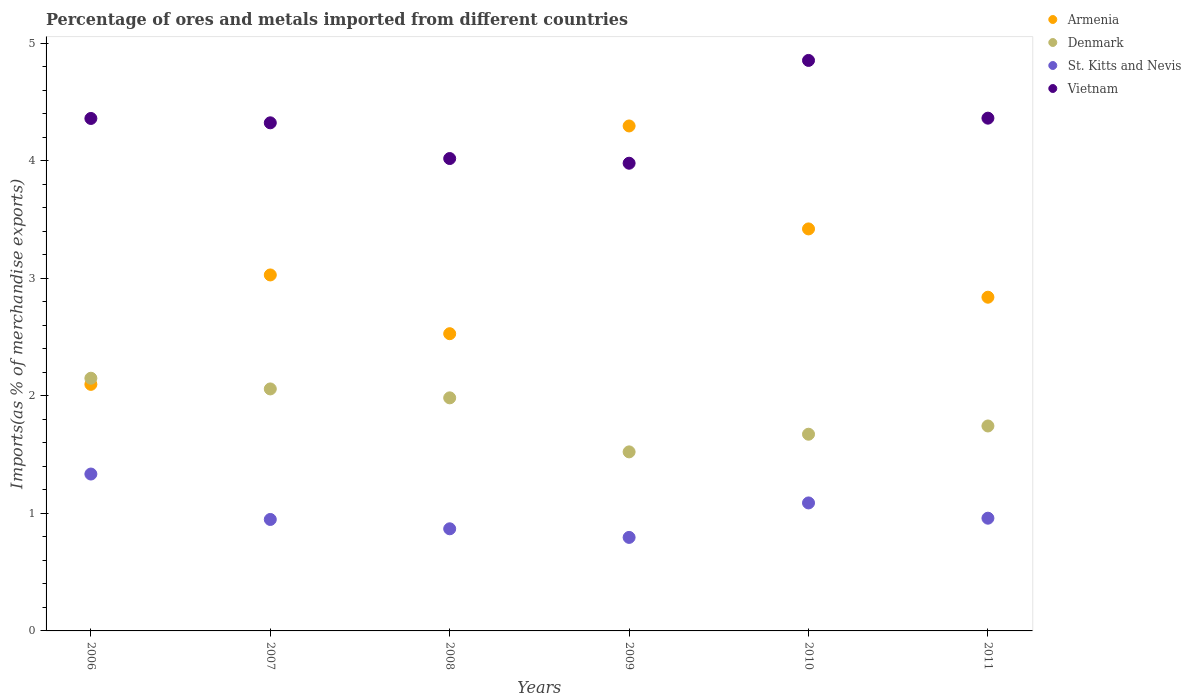How many different coloured dotlines are there?
Ensure brevity in your answer.  4. What is the percentage of imports to different countries in Vietnam in 2009?
Your answer should be compact. 3.98. Across all years, what is the maximum percentage of imports to different countries in Denmark?
Give a very brief answer. 2.15. Across all years, what is the minimum percentage of imports to different countries in Denmark?
Give a very brief answer. 1.52. In which year was the percentage of imports to different countries in Vietnam maximum?
Make the answer very short. 2010. What is the total percentage of imports to different countries in Denmark in the graph?
Provide a succinct answer. 11.13. What is the difference between the percentage of imports to different countries in St. Kitts and Nevis in 2006 and that in 2011?
Provide a short and direct response. 0.38. What is the difference between the percentage of imports to different countries in Denmark in 2011 and the percentage of imports to different countries in Armenia in 2009?
Your response must be concise. -2.55. What is the average percentage of imports to different countries in Armenia per year?
Give a very brief answer. 3.04. In the year 2010, what is the difference between the percentage of imports to different countries in Denmark and percentage of imports to different countries in St. Kitts and Nevis?
Give a very brief answer. 0.58. What is the ratio of the percentage of imports to different countries in Denmark in 2008 to that in 2009?
Offer a terse response. 1.3. Is the difference between the percentage of imports to different countries in Denmark in 2008 and 2009 greater than the difference between the percentage of imports to different countries in St. Kitts and Nevis in 2008 and 2009?
Make the answer very short. Yes. What is the difference between the highest and the second highest percentage of imports to different countries in St. Kitts and Nevis?
Offer a very short reply. 0.25. What is the difference between the highest and the lowest percentage of imports to different countries in Denmark?
Keep it short and to the point. 0.63. In how many years, is the percentage of imports to different countries in Armenia greater than the average percentage of imports to different countries in Armenia taken over all years?
Keep it short and to the point. 2. Is it the case that in every year, the sum of the percentage of imports to different countries in Denmark and percentage of imports to different countries in St. Kitts and Nevis  is greater than the sum of percentage of imports to different countries in Vietnam and percentage of imports to different countries in Armenia?
Keep it short and to the point. Yes. Is it the case that in every year, the sum of the percentage of imports to different countries in Denmark and percentage of imports to different countries in Vietnam  is greater than the percentage of imports to different countries in Armenia?
Offer a terse response. Yes. How many dotlines are there?
Offer a terse response. 4. Does the graph contain any zero values?
Give a very brief answer. No. Does the graph contain grids?
Offer a very short reply. No. How many legend labels are there?
Give a very brief answer. 4. How are the legend labels stacked?
Your answer should be very brief. Vertical. What is the title of the graph?
Offer a terse response. Percentage of ores and metals imported from different countries. What is the label or title of the Y-axis?
Give a very brief answer. Imports(as % of merchandise exports). What is the Imports(as % of merchandise exports) of Armenia in 2006?
Your answer should be very brief. 2.1. What is the Imports(as % of merchandise exports) in Denmark in 2006?
Provide a short and direct response. 2.15. What is the Imports(as % of merchandise exports) in St. Kitts and Nevis in 2006?
Provide a short and direct response. 1.33. What is the Imports(as % of merchandise exports) of Vietnam in 2006?
Ensure brevity in your answer.  4.36. What is the Imports(as % of merchandise exports) in Armenia in 2007?
Offer a very short reply. 3.03. What is the Imports(as % of merchandise exports) in Denmark in 2007?
Offer a very short reply. 2.06. What is the Imports(as % of merchandise exports) in St. Kitts and Nevis in 2007?
Your answer should be compact. 0.95. What is the Imports(as % of merchandise exports) of Vietnam in 2007?
Provide a succinct answer. 4.32. What is the Imports(as % of merchandise exports) of Armenia in 2008?
Give a very brief answer. 2.53. What is the Imports(as % of merchandise exports) in Denmark in 2008?
Provide a succinct answer. 1.98. What is the Imports(as % of merchandise exports) in St. Kitts and Nevis in 2008?
Your answer should be compact. 0.87. What is the Imports(as % of merchandise exports) of Vietnam in 2008?
Your answer should be compact. 4.02. What is the Imports(as % of merchandise exports) of Armenia in 2009?
Give a very brief answer. 4.3. What is the Imports(as % of merchandise exports) of Denmark in 2009?
Your answer should be very brief. 1.52. What is the Imports(as % of merchandise exports) in St. Kitts and Nevis in 2009?
Give a very brief answer. 0.8. What is the Imports(as % of merchandise exports) of Vietnam in 2009?
Provide a short and direct response. 3.98. What is the Imports(as % of merchandise exports) in Armenia in 2010?
Your response must be concise. 3.42. What is the Imports(as % of merchandise exports) of Denmark in 2010?
Your answer should be very brief. 1.67. What is the Imports(as % of merchandise exports) in St. Kitts and Nevis in 2010?
Provide a short and direct response. 1.09. What is the Imports(as % of merchandise exports) in Vietnam in 2010?
Keep it short and to the point. 4.85. What is the Imports(as % of merchandise exports) of Armenia in 2011?
Ensure brevity in your answer.  2.84. What is the Imports(as % of merchandise exports) of Denmark in 2011?
Make the answer very short. 1.74. What is the Imports(as % of merchandise exports) in St. Kitts and Nevis in 2011?
Provide a succinct answer. 0.96. What is the Imports(as % of merchandise exports) in Vietnam in 2011?
Provide a succinct answer. 4.36. Across all years, what is the maximum Imports(as % of merchandise exports) of Armenia?
Give a very brief answer. 4.3. Across all years, what is the maximum Imports(as % of merchandise exports) of Denmark?
Offer a very short reply. 2.15. Across all years, what is the maximum Imports(as % of merchandise exports) of St. Kitts and Nevis?
Offer a very short reply. 1.33. Across all years, what is the maximum Imports(as % of merchandise exports) of Vietnam?
Make the answer very short. 4.85. Across all years, what is the minimum Imports(as % of merchandise exports) in Armenia?
Provide a succinct answer. 2.1. Across all years, what is the minimum Imports(as % of merchandise exports) of Denmark?
Ensure brevity in your answer.  1.52. Across all years, what is the minimum Imports(as % of merchandise exports) in St. Kitts and Nevis?
Offer a very short reply. 0.8. Across all years, what is the minimum Imports(as % of merchandise exports) of Vietnam?
Your answer should be very brief. 3.98. What is the total Imports(as % of merchandise exports) in Armenia in the graph?
Keep it short and to the point. 18.21. What is the total Imports(as % of merchandise exports) of Denmark in the graph?
Make the answer very short. 11.13. What is the total Imports(as % of merchandise exports) in St. Kitts and Nevis in the graph?
Offer a terse response. 6. What is the total Imports(as % of merchandise exports) of Vietnam in the graph?
Your answer should be very brief. 25.9. What is the difference between the Imports(as % of merchandise exports) of Armenia in 2006 and that in 2007?
Keep it short and to the point. -0.93. What is the difference between the Imports(as % of merchandise exports) in Denmark in 2006 and that in 2007?
Provide a succinct answer. 0.09. What is the difference between the Imports(as % of merchandise exports) in St. Kitts and Nevis in 2006 and that in 2007?
Make the answer very short. 0.39. What is the difference between the Imports(as % of merchandise exports) in Vietnam in 2006 and that in 2007?
Your answer should be very brief. 0.04. What is the difference between the Imports(as % of merchandise exports) in Armenia in 2006 and that in 2008?
Your answer should be very brief. -0.43. What is the difference between the Imports(as % of merchandise exports) in Denmark in 2006 and that in 2008?
Offer a very short reply. 0.17. What is the difference between the Imports(as % of merchandise exports) in St. Kitts and Nevis in 2006 and that in 2008?
Give a very brief answer. 0.47. What is the difference between the Imports(as % of merchandise exports) in Vietnam in 2006 and that in 2008?
Provide a short and direct response. 0.34. What is the difference between the Imports(as % of merchandise exports) of Armenia in 2006 and that in 2009?
Your answer should be very brief. -2.2. What is the difference between the Imports(as % of merchandise exports) in Denmark in 2006 and that in 2009?
Ensure brevity in your answer.  0.63. What is the difference between the Imports(as % of merchandise exports) in St. Kitts and Nevis in 2006 and that in 2009?
Provide a succinct answer. 0.54. What is the difference between the Imports(as % of merchandise exports) in Vietnam in 2006 and that in 2009?
Your answer should be compact. 0.38. What is the difference between the Imports(as % of merchandise exports) in Armenia in 2006 and that in 2010?
Ensure brevity in your answer.  -1.32. What is the difference between the Imports(as % of merchandise exports) in Denmark in 2006 and that in 2010?
Provide a short and direct response. 0.48. What is the difference between the Imports(as % of merchandise exports) of St. Kitts and Nevis in 2006 and that in 2010?
Provide a short and direct response. 0.25. What is the difference between the Imports(as % of merchandise exports) in Vietnam in 2006 and that in 2010?
Your answer should be compact. -0.49. What is the difference between the Imports(as % of merchandise exports) in Armenia in 2006 and that in 2011?
Give a very brief answer. -0.74. What is the difference between the Imports(as % of merchandise exports) of Denmark in 2006 and that in 2011?
Offer a terse response. 0.41. What is the difference between the Imports(as % of merchandise exports) in St. Kitts and Nevis in 2006 and that in 2011?
Make the answer very short. 0.38. What is the difference between the Imports(as % of merchandise exports) in Vietnam in 2006 and that in 2011?
Keep it short and to the point. -0. What is the difference between the Imports(as % of merchandise exports) of Armenia in 2007 and that in 2008?
Keep it short and to the point. 0.5. What is the difference between the Imports(as % of merchandise exports) in Denmark in 2007 and that in 2008?
Ensure brevity in your answer.  0.08. What is the difference between the Imports(as % of merchandise exports) of St. Kitts and Nevis in 2007 and that in 2008?
Give a very brief answer. 0.08. What is the difference between the Imports(as % of merchandise exports) in Vietnam in 2007 and that in 2008?
Give a very brief answer. 0.3. What is the difference between the Imports(as % of merchandise exports) of Armenia in 2007 and that in 2009?
Give a very brief answer. -1.27. What is the difference between the Imports(as % of merchandise exports) in Denmark in 2007 and that in 2009?
Offer a terse response. 0.54. What is the difference between the Imports(as % of merchandise exports) of St. Kitts and Nevis in 2007 and that in 2009?
Keep it short and to the point. 0.15. What is the difference between the Imports(as % of merchandise exports) of Vietnam in 2007 and that in 2009?
Ensure brevity in your answer.  0.34. What is the difference between the Imports(as % of merchandise exports) of Armenia in 2007 and that in 2010?
Provide a succinct answer. -0.39. What is the difference between the Imports(as % of merchandise exports) in Denmark in 2007 and that in 2010?
Keep it short and to the point. 0.39. What is the difference between the Imports(as % of merchandise exports) in St. Kitts and Nevis in 2007 and that in 2010?
Your answer should be compact. -0.14. What is the difference between the Imports(as % of merchandise exports) in Vietnam in 2007 and that in 2010?
Give a very brief answer. -0.53. What is the difference between the Imports(as % of merchandise exports) of Armenia in 2007 and that in 2011?
Ensure brevity in your answer.  0.19. What is the difference between the Imports(as % of merchandise exports) of Denmark in 2007 and that in 2011?
Offer a very short reply. 0.32. What is the difference between the Imports(as % of merchandise exports) of St. Kitts and Nevis in 2007 and that in 2011?
Make the answer very short. -0.01. What is the difference between the Imports(as % of merchandise exports) in Vietnam in 2007 and that in 2011?
Ensure brevity in your answer.  -0.04. What is the difference between the Imports(as % of merchandise exports) of Armenia in 2008 and that in 2009?
Make the answer very short. -1.77. What is the difference between the Imports(as % of merchandise exports) in Denmark in 2008 and that in 2009?
Ensure brevity in your answer.  0.46. What is the difference between the Imports(as % of merchandise exports) in St. Kitts and Nevis in 2008 and that in 2009?
Make the answer very short. 0.07. What is the difference between the Imports(as % of merchandise exports) in Vietnam in 2008 and that in 2009?
Keep it short and to the point. 0.04. What is the difference between the Imports(as % of merchandise exports) in Armenia in 2008 and that in 2010?
Give a very brief answer. -0.89. What is the difference between the Imports(as % of merchandise exports) in Denmark in 2008 and that in 2010?
Give a very brief answer. 0.31. What is the difference between the Imports(as % of merchandise exports) in St. Kitts and Nevis in 2008 and that in 2010?
Make the answer very short. -0.22. What is the difference between the Imports(as % of merchandise exports) of Vietnam in 2008 and that in 2010?
Provide a short and direct response. -0.83. What is the difference between the Imports(as % of merchandise exports) of Armenia in 2008 and that in 2011?
Provide a short and direct response. -0.31. What is the difference between the Imports(as % of merchandise exports) of Denmark in 2008 and that in 2011?
Your answer should be very brief. 0.24. What is the difference between the Imports(as % of merchandise exports) in St. Kitts and Nevis in 2008 and that in 2011?
Give a very brief answer. -0.09. What is the difference between the Imports(as % of merchandise exports) in Vietnam in 2008 and that in 2011?
Your answer should be compact. -0.34. What is the difference between the Imports(as % of merchandise exports) in Armenia in 2009 and that in 2010?
Make the answer very short. 0.88. What is the difference between the Imports(as % of merchandise exports) in Denmark in 2009 and that in 2010?
Provide a short and direct response. -0.15. What is the difference between the Imports(as % of merchandise exports) of St. Kitts and Nevis in 2009 and that in 2010?
Ensure brevity in your answer.  -0.29. What is the difference between the Imports(as % of merchandise exports) of Vietnam in 2009 and that in 2010?
Give a very brief answer. -0.87. What is the difference between the Imports(as % of merchandise exports) of Armenia in 2009 and that in 2011?
Provide a succinct answer. 1.46. What is the difference between the Imports(as % of merchandise exports) of Denmark in 2009 and that in 2011?
Keep it short and to the point. -0.22. What is the difference between the Imports(as % of merchandise exports) of St. Kitts and Nevis in 2009 and that in 2011?
Make the answer very short. -0.16. What is the difference between the Imports(as % of merchandise exports) in Vietnam in 2009 and that in 2011?
Your response must be concise. -0.38. What is the difference between the Imports(as % of merchandise exports) in Armenia in 2010 and that in 2011?
Your answer should be very brief. 0.58. What is the difference between the Imports(as % of merchandise exports) of Denmark in 2010 and that in 2011?
Keep it short and to the point. -0.07. What is the difference between the Imports(as % of merchandise exports) of St. Kitts and Nevis in 2010 and that in 2011?
Your answer should be very brief. 0.13. What is the difference between the Imports(as % of merchandise exports) of Vietnam in 2010 and that in 2011?
Give a very brief answer. 0.49. What is the difference between the Imports(as % of merchandise exports) of Armenia in 2006 and the Imports(as % of merchandise exports) of Denmark in 2007?
Your response must be concise. 0.04. What is the difference between the Imports(as % of merchandise exports) in Armenia in 2006 and the Imports(as % of merchandise exports) in St. Kitts and Nevis in 2007?
Provide a short and direct response. 1.15. What is the difference between the Imports(as % of merchandise exports) in Armenia in 2006 and the Imports(as % of merchandise exports) in Vietnam in 2007?
Provide a succinct answer. -2.23. What is the difference between the Imports(as % of merchandise exports) in Denmark in 2006 and the Imports(as % of merchandise exports) in St. Kitts and Nevis in 2007?
Give a very brief answer. 1.2. What is the difference between the Imports(as % of merchandise exports) of Denmark in 2006 and the Imports(as % of merchandise exports) of Vietnam in 2007?
Ensure brevity in your answer.  -2.17. What is the difference between the Imports(as % of merchandise exports) in St. Kitts and Nevis in 2006 and the Imports(as % of merchandise exports) in Vietnam in 2007?
Make the answer very short. -2.99. What is the difference between the Imports(as % of merchandise exports) of Armenia in 2006 and the Imports(as % of merchandise exports) of Denmark in 2008?
Provide a short and direct response. 0.11. What is the difference between the Imports(as % of merchandise exports) in Armenia in 2006 and the Imports(as % of merchandise exports) in St. Kitts and Nevis in 2008?
Your answer should be compact. 1.23. What is the difference between the Imports(as % of merchandise exports) in Armenia in 2006 and the Imports(as % of merchandise exports) in Vietnam in 2008?
Ensure brevity in your answer.  -1.92. What is the difference between the Imports(as % of merchandise exports) in Denmark in 2006 and the Imports(as % of merchandise exports) in St. Kitts and Nevis in 2008?
Provide a short and direct response. 1.28. What is the difference between the Imports(as % of merchandise exports) of Denmark in 2006 and the Imports(as % of merchandise exports) of Vietnam in 2008?
Offer a terse response. -1.87. What is the difference between the Imports(as % of merchandise exports) of St. Kitts and Nevis in 2006 and the Imports(as % of merchandise exports) of Vietnam in 2008?
Your answer should be very brief. -2.68. What is the difference between the Imports(as % of merchandise exports) in Armenia in 2006 and the Imports(as % of merchandise exports) in Denmark in 2009?
Offer a terse response. 0.57. What is the difference between the Imports(as % of merchandise exports) in Armenia in 2006 and the Imports(as % of merchandise exports) in St. Kitts and Nevis in 2009?
Ensure brevity in your answer.  1.3. What is the difference between the Imports(as % of merchandise exports) of Armenia in 2006 and the Imports(as % of merchandise exports) of Vietnam in 2009?
Your answer should be very brief. -1.88. What is the difference between the Imports(as % of merchandise exports) of Denmark in 2006 and the Imports(as % of merchandise exports) of St. Kitts and Nevis in 2009?
Ensure brevity in your answer.  1.35. What is the difference between the Imports(as % of merchandise exports) of Denmark in 2006 and the Imports(as % of merchandise exports) of Vietnam in 2009?
Make the answer very short. -1.83. What is the difference between the Imports(as % of merchandise exports) of St. Kitts and Nevis in 2006 and the Imports(as % of merchandise exports) of Vietnam in 2009?
Your response must be concise. -2.64. What is the difference between the Imports(as % of merchandise exports) in Armenia in 2006 and the Imports(as % of merchandise exports) in Denmark in 2010?
Provide a succinct answer. 0.42. What is the difference between the Imports(as % of merchandise exports) of Armenia in 2006 and the Imports(as % of merchandise exports) of St. Kitts and Nevis in 2010?
Your answer should be compact. 1.01. What is the difference between the Imports(as % of merchandise exports) of Armenia in 2006 and the Imports(as % of merchandise exports) of Vietnam in 2010?
Give a very brief answer. -2.76. What is the difference between the Imports(as % of merchandise exports) in Denmark in 2006 and the Imports(as % of merchandise exports) in St. Kitts and Nevis in 2010?
Your answer should be compact. 1.06. What is the difference between the Imports(as % of merchandise exports) in Denmark in 2006 and the Imports(as % of merchandise exports) in Vietnam in 2010?
Provide a succinct answer. -2.7. What is the difference between the Imports(as % of merchandise exports) of St. Kitts and Nevis in 2006 and the Imports(as % of merchandise exports) of Vietnam in 2010?
Provide a short and direct response. -3.52. What is the difference between the Imports(as % of merchandise exports) of Armenia in 2006 and the Imports(as % of merchandise exports) of Denmark in 2011?
Your answer should be very brief. 0.35. What is the difference between the Imports(as % of merchandise exports) in Armenia in 2006 and the Imports(as % of merchandise exports) in St. Kitts and Nevis in 2011?
Ensure brevity in your answer.  1.14. What is the difference between the Imports(as % of merchandise exports) of Armenia in 2006 and the Imports(as % of merchandise exports) of Vietnam in 2011?
Provide a succinct answer. -2.26. What is the difference between the Imports(as % of merchandise exports) in Denmark in 2006 and the Imports(as % of merchandise exports) in St. Kitts and Nevis in 2011?
Give a very brief answer. 1.19. What is the difference between the Imports(as % of merchandise exports) in Denmark in 2006 and the Imports(as % of merchandise exports) in Vietnam in 2011?
Ensure brevity in your answer.  -2.21. What is the difference between the Imports(as % of merchandise exports) in St. Kitts and Nevis in 2006 and the Imports(as % of merchandise exports) in Vietnam in 2011?
Your answer should be compact. -3.03. What is the difference between the Imports(as % of merchandise exports) of Armenia in 2007 and the Imports(as % of merchandise exports) of Denmark in 2008?
Your response must be concise. 1.05. What is the difference between the Imports(as % of merchandise exports) of Armenia in 2007 and the Imports(as % of merchandise exports) of St. Kitts and Nevis in 2008?
Provide a short and direct response. 2.16. What is the difference between the Imports(as % of merchandise exports) in Armenia in 2007 and the Imports(as % of merchandise exports) in Vietnam in 2008?
Your response must be concise. -0.99. What is the difference between the Imports(as % of merchandise exports) in Denmark in 2007 and the Imports(as % of merchandise exports) in St. Kitts and Nevis in 2008?
Provide a succinct answer. 1.19. What is the difference between the Imports(as % of merchandise exports) in Denmark in 2007 and the Imports(as % of merchandise exports) in Vietnam in 2008?
Offer a very short reply. -1.96. What is the difference between the Imports(as % of merchandise exports) in St. Kitts and Nevis in 2007 and the Imports(as % of merchandise exports) in Vietnam in 2008?
Offer a terse response. -3.07. What is the difference between the Imports(as % of merchandise exports) in Armenia in 2007 and the Imports(as % of merchandise exports) in Denmark in 2009?
Your answer should be very brief. 1.51. What is the difference between the Imports(as % of merchandise exports) in Armenia in 2007 and the Imports(as % of merchandise exports) in St. Kitts and Nevis in 2009?
Give a very brief answer. 2.23. What is the difference between the Imports(as % of merchandise exports) in Armenia in 2007 and the Imports(as % of merchandise exports) in Vietnam in 2009?
Provide a short and direct response. -0.95. What is the difference between the Imports(as % of merchandise exports) in Denmark in 2007 and the Imports(as % of merchandise exports) in St. Kitts and Nevis in 2009?
Give a very brief answer. 1.26. What is the difference between the Imports(as % of merchandise exports) of Denmark in 2007 and the Imports(as % of merchandise exports) of Vietnam in 2009?
Make the answer very short. -1.92. What is the difference between the Imports(as % of merchandise exports) in St. Kitts and Nevis in 2007 and the Imports(as % of merchandise exports) in Vietnam in 2009?
Provide a succinct answer. -3.03. What is the difference between the Imports(as % of merchandise exports) of Armenia in 2007 and the Imports(as % of merchandise exports) of Denmark in 2010?
Your answer should be compact. 1.36. What is the difference between the Imports(as % of merchandise exports) of Armenia in 2007 and the Imports(as % of merchandise exports) of St. Kitts and Nevis in 2010?
Your answer should be very brief. 1.94. What is the difference between the Imports(as % of merchandise exports) in Armenia in 2007 and the Imports(as % of merchandise exports) in Vietnam in 2010?
Make the answer very short. -1.83. What is the difference between the Imports(as % of merchandise exports) in Denmark in 2007 and the Imports(as % of merchandise exports) in Vietnam in 2010?
Ensure brevity in your answer.  -2.79. What is the difference between the Imports(as % of merchandise exports) in St. Kitts and Nevis in 2007 and the Imports(as % of merchandise exports) in Vietnam in 2010?
Your answer should be very brief. -3.91. What is the difference between the Imports(as % of merchandise exports) in Armenia in 2007 and the Imports(as % of merchandise exports) in Denmark in 2011?
Provide a short and direct response. 1.28. What is the difference between the Imports(as % of merchandise exports) in Armenia in 2007 and the Imports(as % of merchandise exports) in St. Kitts and Nevis in 2011?
Offer a terse response. 2.07. What is the difference between the Imports(as % of merchandise exports) of Armenia in 2007 and the Imports(as % of merchandise exports) of Vietnam in 2011?
Keep it short and to the point. -1.33. What is the difference between the Imports(as % of merchandise exports) in Denmark in 2007 and the Imports(as % of merchandise exports) in St. Kitts and Nevis in 2011?
Give a very brief answer. 1.1. What is the difference between the Imports(as % of merchandise exports) in Denmark in 2007 and the Imports(as % of merchandise exports) in Vietnam in 2011?
Your answer should be very brief. -2.3. What is the difference between the Imports(as % of merchandise exports) in St. Kitts and Nevis in 2007 and the Imports(as % of merchandise exports) in Vietnam in 2011?
Your answer should be compact. -3.41. What is the difference between the Imports(as % of merchandise exports) in Armenia in 2008 and the Imports(as % of merchandise exports) in St. Kitts and Nevis in 2009?
Provide a short and direct response. 1.73. What is the difference between the Imports(as % of merchandise exports) of Armenia in 2008 and the Imports(as % of merchandise exports) of Vietnam in 2009?
Give a very brief answer. -1.45. What is the difference between the Imports(as % of merchandise exports) in Denmark in 2008 and the Imports(as % of merchandise exports) in St. Kitts and Nevis in 2009?
Ensure brevity in your answer.  1.19. What is the difference between the Imports(as % of merchandise exports) of Denmark in 2008 and the Imports(as % of merchandise exports) of Vietnam in 2009?
Provide a short and direct response. -2. What is the difference between the Imports(as % of merchandise exports) of St. Kitts and Nevis in 2008 and the Imports(as % of merchandise exports) of Vietnam in 2009?
Your response must be concise. -3.11. What is the difference between the Imports(as % of merchandise exports) of Armenia in 2008 and the Imports(as % of merchandise exports) of Denmark in 2010?
Offer a very short reply. 0.86. What is the difference between the Imports(as % of merchandise exports) of Armenia in 2008 and the Imports(as % of merchandise exports) of St. Kitts and Nevis in 2010?
Give a very brief answer. 1.44. What is the difference between the Imports(as % of merchandise exports) in Armenia in 2008 and the Imports(as % of merchandise exports) in Vietnam in 2010?
Give a very brief answer. -2.33. What is the difference between the Imports(as % of merchandise exports) in Denmark in 2008 and the Imports(as % of merchandise exports) in St. Kitts and Nevis in 2010?
Your answer should be very brief. 0.89. What is the difference between the Imports(as % of merchandise exports) of Denmark in 2008 and the Imports(as % of merchandise exports) of Vietnam in 2010?
Keep it short and to the point. -2.87. What is the difference between the Imports(as % of merchandise exports) in St. Kitts and Nevis in 2008 and the Imports(as % of merchandise exports) in Vietnam in 2010?
Provide a succinct answer. -3.98. What is the difference between the Imports(as % of merchandise exports) in Armenia in 2008 and the Imports(as % of merchandise exports) in Denmark in 2011?
Ensure brevity in your answer.  0.79. What is the difference between the Imports(as % of merchandise exports) in Armenia in 2008 and the Imports(as % of merchandise exports) in St. Kitts and Nevis in 2011?
Make the answer very short. 1.57. What is the difference between the Imports(as % of merchandise exports) of Armenia in 2008 and the Imports(as % of merchandise exports) of Vietnam in 2011?
Your answer should be very brief. -1.83. What is the difference between the Imports(as % of merchandise exports) in Denmark in 2008 and the Imports(as % of merchandise exports) in St. Kitts and Nevis in 2011?
Your response must be concise. 1.02. What is the difference between the Imports(as % of merchandise exports) in Denmark in 2008 and the Imports(as % of merchandise exports) in Vietnam in 2011?
Provide a succinct answer. -2.38. What is the difference between the Imports(as % of merchandise exports) of St. Kitts and Nevis in 2008 and the Imports(as % of merchandise exports) of Vietnam in 2011?
Provide a succinct answer. -3.49. What is the difference between the Imports(as % of merchandise exports) of Armenia in 2009 and the Imports(as % of merchandise exports) of Denmark in 2010?
Provide a succinct answer. 2.62. What is the difference between the Imports(as % of merchandise exports) of Armenia in 2009 and the Imports(as % of merchandise exports) of St. Kitts and Nevis in 2010?
Give a very brief answer. 3.21. What is the difference between the Imports(as % of merchandise exports) in Armenia in 2009 and the Imports(as % of merchandise exports) in Vietnam in 2010?
Provide a succinct answer. -0.56. What is the difference between the Imports(as % of merchandise exports) of Denmark in 2009 and the Imports(as % of merchandise exports) of St. Kitts and Nevis in 2010?
Your response must be concise. 0.43. What is the difference between the Imports(as % of merchandise exports) in Denmark in 2009 and the Imports(as % of merchandise exports) in Vietnam in 2010?
Ensure brevity in your answer.  -3.33. What is the difference between the Imports(as % of merchandise exports) of St. Kitts and Nevis in 2009 and the Imports(as % of merchandise exports) of Vietnam in 2010?
Offer a very short reply. -4.06. What is the difference between the Imports(as % of merchandise exports) in Armenia in 2009 and the Imports(as % of merchandise exports) in Denmark in 2011?
Make the answer very short. 2.55. What is the difference between the Imports(as % of merchandise exports) of Armenia in 2009 and the Imports(as % of merchandise exports) of St. Kitts and Nevis in 2011?
Provide a short and direct response. 3.34. What is the difference between the Imports(as % of merchandise exports) of Armenia in 2009 and the Imports(as % of merchandise exports) of Vietnam in 2011?
Your response must be concise. -0.07. What is the difference between the Imports(as % of merchandise exports) in Denmark in 2009 and the Imports(as % of merchandise exports) in St. Kitts and Nevis in 2011?
Ensure brevity in your answer.  0.56. What is the difference between the Imports(as % of merchandise exports) in Denmark in 2009 and the Imports(as % of merchandise exports) in Vietnam in 2011?
Give a very brief answer. -2.84. What is the difference between the Imports(as % of merchandise exports) in St. Kitts and Nevis in 2009 and the Imports(as % of merchandise exports) in Vietnam in 2011?
Offer a terse response. -3.57. What is the difference between the Imports(as % of merchandise exports) in Armenia in 2010 and the Imports(as % of merchandise exports) in Denmark in 2011?
Offer a very short reply. 1.68. What is the difference between the Imports(as % of merchandise exports) of Armenia in 2010 and the Imports(as % of merchandise exports) of St. Kitts and Nevis in 2011?
Provide a succinct answer. 2.46. What is the difference between the Imports(as % of merchandise exports) in Armenia in 2010 and the Imports(as % of merchandise exports) in Vietnam in 2011?
Keep it short and to the point. -0.94. What is the difference between the Imports(as % of merchandise exports) of Denmark in 2010 and the Imports(as % of merchandise exports) of St. Kitts and Nevis in 2011?
Make the answer very short. 0.71. What is the difference between the Imports(as % of merchandise exports) of Denmark in 2010 and the Imports(as % of merchandise exports) of Vietnam in 2011?
Offer a terse response. -2.69. What is the difference between the Imports(as % of merchandise exports) in St. Kitts and Nevis in 2010 and the Imports(as % of merchandise exports) in Vietnam in 2011?
Provide a short and direct response. -3.27. What is the average Imports(as % of merchandise exports) in Armenia per year?
Give a very brief answer. 3.04. What is the average Imports(as % of merchandise exports) in Denmark per year?
Your answer should be compact. 1.86. What is the average Imports(as % of merchandise exports) in Vietnam per year?
Provide a succinct answer. 4.32. In the year 2006, what is the difference between the Imports(as % of merchandise exports) of Armenia and Imports(as % of merchandise exports) of Denmark?
Make the answer very short. -0.05. In the year 2006, what is the difference between the Imports(as % of merchandise exports) of Armenia and Imports(as % of merchandise exports) of St. Kitts and Nevis?
Your answer should be very brief. 0.76. In the year 2006, what is the difference between the Imports(as % of merchandise exports) of Armenia and Imports(as % of merchandise exports) of Vietnam?
Keep it short and to the point. -2.26. In the year 2006, what is the difference between the Imports(as % of merchandise exports) of Denmark and Imports(as % of merchandise exports) of St. Kitts and Nevis?
Your answer should be compact. 0.82. In the year 2006, what is the difference between the Imports(as % of merchandise exports) in Denmark and Imports(as % of merchandise exports) in Vietnam?
Ensure brevity in your answer.  -2.21. In the year 2006, what is the difference between the Imports(as % of merchandise exports) of St. Kitts and Nevis and Imports(as % of merchandise exports) of Vietnam?
Give a very brief answer. -3.03. In the year 2007, what is the difference between the Imports(as % of merchandise exports) of Armenia and Imports(as % of merchandise exports) of Denmark?
Keep it short and to the point. 0.97. In the year 2007, what is the difference between the Imports(as % of merchandise exports) of Armenia and Imports(as % of merchandise exports) of St. Kitts and Nevis?
Your response must be concise. 2.08. In the year 2007, what is the difference between the Imports(as % of merchandise exports) of Armenia and Imports(as % of merchandise exports) of Vietnam?
Make the answer very short. -1.29. In the year 2007, what is the difference between the Imports(as % of merchandise exports) in Denmark and Imports(as % of merchandise exports) in St. Kitts and Nevis?
Ensure brevity in your answer.  1.11. In the year 2007, what is the difference between the Imports(as % of merchandise exports) of Denmark and Imports(as % of merchandise exports) of Vietnam?
Ensure brevity in your answer.  -2.26. In the year 2007, what is the difference between the Imports(as % of merchandise exports) in St. Kitts and Nevis and Imports(as % of merchandise exports) in Vietnam?
Give a very brief answer. -3.37. In the year 2008, what is the difference between the Imports(as % of merchandise exports) of Armenia and Imports(as % of merchandise exports) of Denmark?
Keep it short and to the point. 0.55. In the year 2008, what is the difference between the Imports(as % of merchandise exports) in Armenia and Imports(as % of merchandise exports) in St. Kitts and Nevis?
Provide a succinct answer. 1.66. In the year 2008, what is the difference between the Imports(as % of merchandise exports) in Armenia and Imports(as % of merchandise exports) in Vietnam?
Provide a succinct answer. -1.49. In the year 2008, what is the difference between the Imports(as % of merchandise exports) of Denmark and Imports(as % of merchandise exports) of St. Kitts and Nevis?
Give a very brief answer. 1.11. In the year 2008, what is the difference between the Imports(as % of merchandise exports) in Denmark and Imports(as % of merchandise exports) in Vietnam?
Provide a short and direct response. -2.04. In the year 2008, what is the difference between the Imports(as % of merchandise exports) of St. Kitts and Nevis and Imports(as % of merchandise exports) of Vietnam?
Your answer should be compact. -3.15. In the year 2009, what is the difference between the Imports(as % of merchandise exports) in Armenia and Imports(as % of merchandise exports) in Denmark?
Your answer should be compact. 2.77. In the year 2009, what is the difference between the Imports(as % of merchandise exports) of Armenia and Imports(as % of merchandise exports) of St. Kitts and Nevis?
Keep it short and to the point. 3.5. In the year 2009, what is the difference between the Imports(as % of merchandise exports) of Armenia and Imports(as % of merchandise exports) of Vietnam?
Your answer should be compact. 0.32. In the year 2009, what is the difference between the Imports(as % of merchandise exports) in Denmark and Imports(as % of merchandise exports) in St. Kitts and Nevis?
Provide a succinct answer. 0.73. In the year 2009, what is the difference between the Imports(as % of merchandise exports) in Denmark and Imports(as % of merchandise exports) in Vietnam?
Offer a very short reply. -2.46. In the year 2009, what is the difference between the Imports(as % of merchandise exports) in St. Kitts and Nevis and Imports(as % of merchandise exports) in Vietnam?
Give a very brief answer. -3.18. In the year 2010, what is the difference between the Imports(as % of merchandise exports) in Armenia and Imports(as % of merchandise exports) in Denmark?
Ensure brevity in your answer.  1.75. In the year 2010, what is the difference between the Imports(as % of merchandise exports) of Armenia and Imports(as % of merchandise exports) of St. Kitts and Nevis?
Provide a succinct answer. 2.33. In the year 2010, what is the difference between the Imports(as % of merchandise exports) of Armenia and Imports(as % of merchandise exports) of Vietnam?
Provide a succinct answer. -1.43. In the year 2010, what is the difference between the Imports(as % of merchandise exports) in Denmark and Imports(as % of merchandise exports) in St. Kitts and Nevis?
Provide a succinct answer. 0.58. In the year 2010, what is the difference between the Imports(as % of merchandise exports) in Denmark and Imports(as % of merchandise exports) in Vietnam?
Make the answer very short. -3.18. In the year 2010, what is the difference between the Imports(as % of merchandise exports) of St. Kitts and Nevis and Imports(as % of merchandise exports) of Vietnam?
Provide a short and direct response. -3.76. In the year 2011, what is the difference between the Imports(as % of merchandise exports) of Armenia and Imports(as % of merchandise exports) of Denmark?
Offer a terse response. 1.1. In the year 2011, what is the difference between the Imports(as % of merchandise exports) in Armenia and Imports(as % of merchandise exports) in St. Kitts and Nevis?
Provide a succinct answer. 1.88. In the year 2011, what is the difference between the Imports(as % of merchandise exports) of Armenia and Imports(as % of merchandise exports) of Vietnam?
Your response must be concise. -1.52. In the year 2011, what is the difference between the Imports(as % of merchandise exports) in Denmark and Imports(as % of merchandise exports) in St. Kitts and Nevis?
Provide a short and direct response. 0.78. In the year 2011, what is the difference between the Imports(as % of merchandise exports) of Denmark and Imports(as % of merchandise exports) of Vietnam?
Offer a very short reply. -2.62. In the year 2011, what is the difference between the Imports(as % of merchandise exports) of St. Kitts and Nevis and Imports(as % of merchandise exports) of Vietnam?
Give a very brief answer. -3.4. What is the ratio of the Imports(as % of merchandise exports) of Armenia in 2006 to that in 2007?
Provide a short and direct response. 0.69. What is the ratio of the Imports(as % of merchandise exports) of Denmark in 2006 to that in 2007?
Offer a very short reply. 1.04. What is the ratio of the Imports(as % of merchandise exports) in St. Kitts and Nevis in 2006 to that in 2007?
Offer a very short reply. 1.41. What is the ratio of the Imports(as % of merchandise exports) of Vietnam in 2006 to that in 2007?
Provide a short and direct response. 1.01. What is the ratio of the Imports(as % of merchandise exports) in Armenia in 2006 to that in 2008?
Give a very brief answer. 0.83. What is the ratio of the Imports(as % of merchandise exports) in Denmark in 2006 to that in 2008?
Provide a succinct answer. 1.08. What is the ratio of the Imports(as % of merchandise exports) in St. Kitts and Nevis in 2006 to that in 2008?
Offer a very short reply. 1.54. What is the ratio of the Imports(as % of merchandise exports) of Vietnam in 2006 to that in 2008?
Keep it short and to the point. 1.08. What is the ratio of the Imports(as % of merchandise exports) of Armenia in 2006 to that in 2009?
Your answer should be compact. 0.49. What is the ratio of the Imports(as % of merchandise exports) of Denmark in 2006 to that in 2009?
Ensure brevity in your answer.  1.41. What is the ratio of the Imports(as % of merchandise exports) of St. Kitts and Nevis in 2006 to that in 2009?
Give a very brief answer. 1.68. What is the ratio of the Imports(as % of merchandise exports) of Vietnam in 2006 to that in 2009?
Offer a very short reply. 1.1. What is the ratio of the Imports(as % of merchandise exports) in Armenia in 2006 to that in 2010?
Provide a short and direct response. 0.61. What is the ratio of the Imports(as % of merchandise exports) in Denmark in 2006 to that in 2010?
Provide a short and direct response. 1.28. What is the ratio of the Imports(as % of merchandise exports) of St. Kitts and Nevis in 2006 to that in 2010?
Offer a very short reply. 1.23. What is the ratio of the Imports(as % of merchandise exports) in Vietnam in 2006 to that in 2010?
Offer a terse response. 0.9. What is the ratio of the Imports(as % of merchandise exports) in Armenia in 2006 to that in 2011?
Your response must be concise. 0.74. What is the ratio of the Imports(as % of merchandise exports) of Denmark in 2006 to that in 2011?
Your answer should be very brief. 1.23. What is the ratio of the Imports(as % of merchandise exports) of St. Kitts and Nevis in 2006 to that in 2011?
Your response must be concise. 1.39. What is the ratio of the Imports(as % of merchandise exports) of Vietnam in 2006 to that in 2011?
Your answer should be compact. 1. What is the ratio of the Imports(as % of merchandise exports) of Armenia in 2007 to that in 2008?
Your answer should be very brief. 1.2. What is the ratio of the Imports(as % of merchandise exports) of Denmark in 2007 to that in 2008?
Your response must be concise. 1.04. What is the ratio of the Imports(as % of merchandise exports) of St. Kitts and Nevis in 2007 to that in 2008?
Offer a terse response. 1.09. What is the ratio of the Imports(as % of merchandise exports) of Vietnam in 2007 to that in 2008?
Offer a very short reply. 1.08. What is the ratio of the Imports(as % of merchandise exports) of Armenia in 2007 to that in 2009?
Provide a succinct answer. 0.7. What is the ratio of the Imports(as % of merchandise exports) of Denmark in 2007 to that in 2009?
Make the answer very short. 1.35. What is the ratio of the Imports(as % of merchandise exports) in St. Kitts and Nevis in 2007 to that in 2009?
Make the answer very short. 1.19. What is the ratio of the Imports(as % of merchandise exports) in Vietnam in 2007 to that in 2009?
Ensure brevity in your answer.  1.09. What is the ratio of the Imports(as % of merchandise exports) in Armenia in 2007 to that in 2010?
Offer a terse response. 0.89. What is the ratio of the Imports(as % of merchandise exports) in Denmark in 2007 to that in 2010?
Provide a short and direct response. 1.23. What is the ratio of the Imports(as % of merchandise exports) of St. Kitts and Nevis in 2007 to that in 2010?
Offer a very short reply. 0.87. What is the ratio of the Imports(as % of merchandise exports) in Vietnam in 2007 to that in 2010?
Give a very brief answer. 0.89. What is the ratio of the Imports(as % of merchandise exports) in Armenia in 2007 to that in 2011?
Ensure brevity in your answer.  1.07. What is the ratio of the Imports(as % of merchandise exports) of Denmark in 2007 to that in 2011?
Your answer should be compact. 1.18. What is the ratio of the Imports(as % of merchandise exports) in St. Kitts and Nevis in 2007 to that in 2011?
Your answer should be very brief. 0.99. What is the ratio of the Imports(as % of merchandise exports) of Vietnam in 2007 to that in 2011?
Offer a terse response. 0.99. What is the ratio of the Imports(as % of merchandise exports) in Armenia in 2008 to that in 2009?
Make the answer very short. 0.59. What is the ratio of the Imports(as % of merchandise exports) in Denmark in 2008 to that in 2009?
Provide a short and direct response. 1.3. What is the ratio of the Imports(as % of merchandise exports) in St. Kitts and Nevis in 2008 to that in 2009?
Keep it short and to the point. 1.09. What is the ratio of the Imports(as % of merchandise exports) of Armenia in 2008 to that in 2010?
Your answer should be very brief. 0.74. What is the ratio of the Imports(as % of merchandise exports) in Denmark in 2008 to that in 2010?
Give a very brief answer. 1.18. What is the ratio of the Imports(as % of merchandise exports) of St. Kitts and Nevis in 2008 to that in 2010?
Your answer should be very brief. 0.8. What is the ratio of the Imports(as % of merchandise exports) of Vietnam in 2008 to that in 2010?
Ensure brevity in your answer.  0.83. What is the ratio of the Imports(as % of merchandise exports) of Armenia in 2008 to that in 2011?
Make the answer very short. 0.89. What is the ratio of the Imports(as % of merchandise exports) in Denmark in 2008 to that in 2011?
Provide a short and direct response. 1.14. What is the ratio of the Imports(as % of merchandise exports) in St. Kitts and Nevis in 2008 to that in 2011?
Your answer should be compact. 0.91. What is the ratio of the Imports(as % of merchandise exports) in Vietnam in 2008 to that in 2011?
Make the answer very short. 0.92. What is the ratio of the Imports(as % of merchandise exports) in Armenia in 2009 to that in 2010?
Make the answer very short. 1.26. What is the ratio of the Imports(as % of merchandise exports) of Denmark in 2009 to that in 2010?
Make the answer very short. 0.91. What is the ratio of the Imports(as % of merchandise exports) in St. Kitts and Nevis in 2009 to that in 2010?
Your answer should be compact. 0.73. What is the ratio of the Imports(as % of merchandise exports) of Vietnam in 2009 to that in 2010?
Provide a succinct answer. 0.82. What is the ratio of the Imports(as % of merchandise exports) of Armenia in 2009 to that in 2011?
Your response must be concise. 1.51. What is the ratio of the Imports(as % of merchandise exports) in Denmark in 2009 to that in 2011?
Offer a very short reply. 0.87. What is the ratio of the Imports(as % of merchandise exports) in St. Kitts and Nevis in 2009 to that in 2011?
Your response must be concise. 0.83. What is the ratio of the Imports(as % of merchandise exports) in Vietnam in 2009 to that in 2011?
Offer a very short reply. 0.91. What is the ratio of the Imports(as % of merchandise exports) of Armenia in 2010 to that in 2011?
Provide a short and direct response. 1.2. What is the ratio of the Imports(as % of merchandise exports) in Denmark in 2010 to that in 2011?
Your response must be concise. 0.96. What is the ratio of the Imports(as % of merchandise exports) of St. Kitts and Nevis in 2010 to that in 2011?
Your answer should be very brief. 1.14. What is the ratio of the Imports(as % of merchandise exports) in Vietnam in 2010 to that in 2011?
Give a very brief answer. 1.11. What is the difference between the highest and the second highest Imports(as % of merchandise exports) of Armenia?
Your response must be concise. 0.88. What is the difference between the highest and the second highest Imports(as % of merchandise exports) in Denmark?
Your answer should be very brief. 0.09. What is the difference between the highest and the second highest Imports(as % of merchandise exports) of St. Kitts and Nevis?
Give a very brief answer. 0.25. What is the difference between the highest and the second highest Imports(as % of merchandise exports) of Vietnam?
Offer a terse response. 0.49. What is the difference between the highest and the lowest Imports(as % of merchandise exports) of Armenia?
Offer a terse response. 2.2. What is the difference between the highest and the lowest Imports(as % of merchandise exports) of Denmark?
Keep it short and to the point. 0.63. What is the difference between the highest and the lowest Imports(as % of merchandise exports) in St. Kitts and Nevis?
Give a very brief answer. 0.54. What is the difference between the highest and the lowest Imports(as % of merchandise exports) in Vietnam?
Make the answer very short. 0.87. 